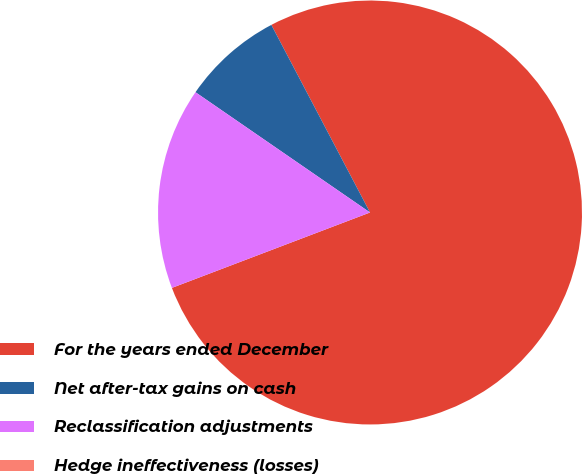Convert chart to OTSL. <chart><loc_0><loc_0><loc_500><loc_500><pie_chart><fcel>For the years ended December<fcel>Net after-tax gains on cash<fcel>Reclassification adjustments<fcel>Hedge ineffectiveness (losses)<nl><fcel>76.92%<fcel>7.69%<fcel>15.39%<fcel>0.0%<nl></chart> 